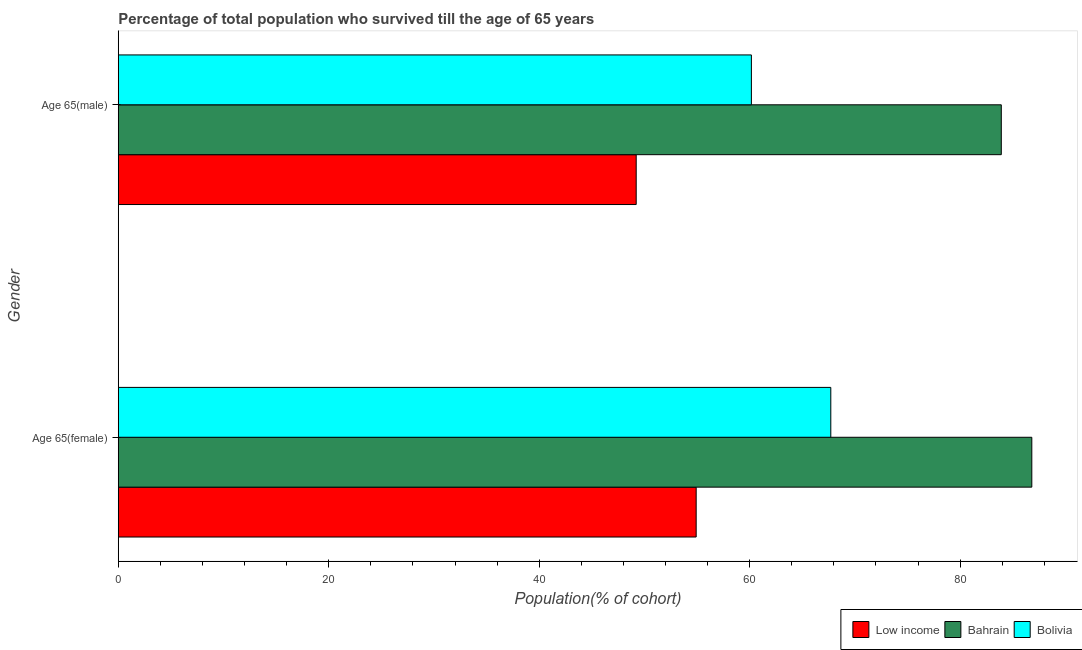How many different coloured bars are there?
Provide a succinct answer. 3. How many groups of bars are there?
Your answer should be compact. 2. Are the number of bars per tick equal to the number of legend labels?
Offer a terse response. Yes. How many bars are there on the 1st tick from the bottom?
Your answer should be very brief. 3. What is the label of the 2nd group of bars from the top?
Keep it short and to the point. Age 65(female). What is the percentage of female population who survived till age of 65 in Bahrain?
Provide a short and direct response. 86.81. Across all countries, what is the maximum percentage of male population who survived till age of 65?
Your answer should be compact. 83.91. Across all countries, what is the minimum percentage of male population who survived till age of 65?
Offer a terse response. 49.22. In which country was the percentage of female population who survived till age of 65 maximum?
Provide a short and direct response. Bahrain. What is the total percentage of female population who survived till age of 65 in the graph?
Your answer should be very brief. 209.43. What is the difference between the percentage of female population who survived till age of 65 in Bahrain and that in Low income?
Your response must be concise. 31.89. What is the difference between the percentage of male population who survived till age of 65 in Low income and the percentage of female population who survived till age of 65 in Bahrain?
Offer a very short reply. -37.59. What is the average percentage of male population who survived till age of 65 per country?
Your answer should be very brief. 64.43. What is the difference between the percentage of male population who survived till age of 65 and percentage of female population who survived till age of 65 in Low income?
Your answer should be very brief. -5.7. In how many countries, is the percentage of male population who survived till age of 65 greater than 16 %?
Your answer should be compact. 3. What is the ratio of the percentage of male population who survived till age of 65 in Bolivia to that in Bahrain?
Make the answer very short. 0.72. What does the 3rd bar from the bottom in Age 65(female) represents?
Give a very brief answer. Bolivia. How many countries are there in the graph?
Make the answer very short. 3. What is the difference between two consecutive major ticks on the X-axis?
Give a very brief answer. 20. Does the graph contain any zero values?
Provide a short and direct response. No. Does the graph contain grids?
Your answer should be compact. No. How are the legend labels stacked?
Your response must be concise. Horizontal. What is the title of the graph?
Offer a very short reply. Percentage of total population who survived till the age of 65 years. Does "Papua New Guinea" appear as one of the legend labels in the graph?
Ensure brevity in your answer.  No. What is the label or title of the X-axis?
Your answer should be compact. Population(% of cohort). What is the label or title of the Y-axis?
Make the answer very short. Gender. What is the Population(% of cohort) in Low income in Age 65(female)?
Ensure brevity in your answer.  54.91. What is the Population(% of cohort) of Bahrain in Age 65(female)?
Offer a very short reply. 86.81. What is the Population(% of cohort) of Bolivia in Age 65(female)?
Offer a terse response. 67.71. What is the Population(% of cohort) of Low income in Age 65(male)?
Provide a short and direct response. 49.22. What is the Population(% of cohort) in Bahrain in Age 65(male)?
Offer a terse response. 83.91. What is the Population(% of cohort) in Bolivia in Age 65(male)?
Keep it short and to the point. 60.16. Across all Gender, what is the maximum Population(% of cohort) of Low income?
Ensure brevity in your answer.  54.91. Across all Gender, what is the maximum Population(% of cohort) in Bahrain?
Offer a terse response. 86.81. Across all Gender, what is the maximum Population(% of cohort) in Bolivia?
Provide a short and direct response. 67.71. Across all Gender, what is the minimum Population(% of cohort) of Low income?
Give a very brief answer. 49.22. Across all Gender, what is the minimum Population(% of cohort) of Bahrain?
Offer a very short reply. 83.91. Across all Gender, what is the minimum Population(% of cohort) of Bolivia?
Your answer should be compact. 60.16. What is the total Population(% of cohort) of Low income in the graph?
Offer a very short reply. 104.13. What is the total Population(% of cohort) of Bahrain in the graph?
Your response must be concise. 170.72. What is the total Population(% of cohort) in Bolivia in the graph?
Ensure brevity in your answer.  127.87. What is the difference between the Population(% of cohort) in Low income in Age 65(female) and that in Age 65(male)?
Provide a succinct answer. 5.7. What is the difference between the Population(% of cohort) of Bahrain in Age 65(female) and that in Age 65(male)?
Offer a very short reply. 2.9. What is the difference between the Population(% of cohort) in Bolivia in Age 65(female) and that in Age 65(male)?
Provide a short and direct response. 7.55. What is the difference between the Population(% of cohort) of Low income in Age 65(female) and the Population(% of cohort) of Bahrain in Age 65(male)?
Offer a terse response. -28.99. What is the difference between the Population(% of cohort) in Low income in Age 65(female) and the Population(% of cohort) in Bolivia in Age 65(male)?
Make the answer very short. -5.25. What is the difference between the Population(% of cohort) of Bahrain in Age 65(female) and the Population(% of cohort) of Bolivia in Age 65(male)?
Provide a succinct answer. 26.65. What is the average Population(% of cohort) in Low income per Gender?
Offer a terse response. 52.06. What is the average Population(% of cohort) of Bahrain per Gender?
Your answer should be compact. 85.36. What is the average Population(% of cohort) in Bolivia per Gender?
Your answer should be very brief. 63.93. What is the difference between the Population(% of cohort) in Low income and Population(% of cohort) in Bahrain in Age 65(female)?
Make the answer very short. -31.89. What is the difference between the Population(% of cohort) in Low income and Population(% of cohort) in Bolivia in Age 65(female)?
Provide a short and direct response. -12.79. What is the difference between the Population(% of cohort) in Bahrain and Population(% of cohort) in Bolivia in Age 65(female)?
Your answer should be compact. 19.1. What is the difference between the Population(% of cohort) in Low income and Population(% of cohort) in Bahrain in Age 65(male)?
Provide a short and direct response. -34.69. What is the difference between the Population(% of cohort) of Low income and Population(% of cohort) of Bolivia in Age 65(male)?
Ensure brevity in your answer.  -10.95. What is the difference between the Population(% of cohort) in Bahrain and Population(% of cohort) in Bolivia in Age 65(male)?
Offer a terse response. 23.75. What is the ratio of the Population(% of cohort) of Low income in Age 65(female) to that in Age 65(male)?
Provide a succinct answer. 1.12. What is the ratio of the Population(% of cohort) of Bahrain in Age 65(female) to that in Age 65(male)?
Your answer should be very brief. 1.03. What is the ratio of the Population(% of cohort) of Bolivia in Age 65(female) to that in Age 65(male)?
Your answer should be very brief. 1.13. What is the difference between the highest and the second highest Population(% of cohort) of Low income?
Ensure brevity in your answer.  5.7. What is the difference between the highest and the second highest Population(% of cohort) in Bahrain?
Ensure brevity in your answer.  2.9. What is the difference between the highest and the second highest Population(% of cohort) of Bolivia?
Provide a succinct answer. 7.55. What is the difference between the highest and the lowest Population(% of cohort) in Low income?
Your answer should be very brief. 5.7. What is the difference between the highest and the lowest Population(% of cohort) in Bahrain?
Provide a short and direct response. 2.9. What is the difference between the highest and the lowest Population(% of cohort) in Bolivia?
Your response must be concise. 7.55. 